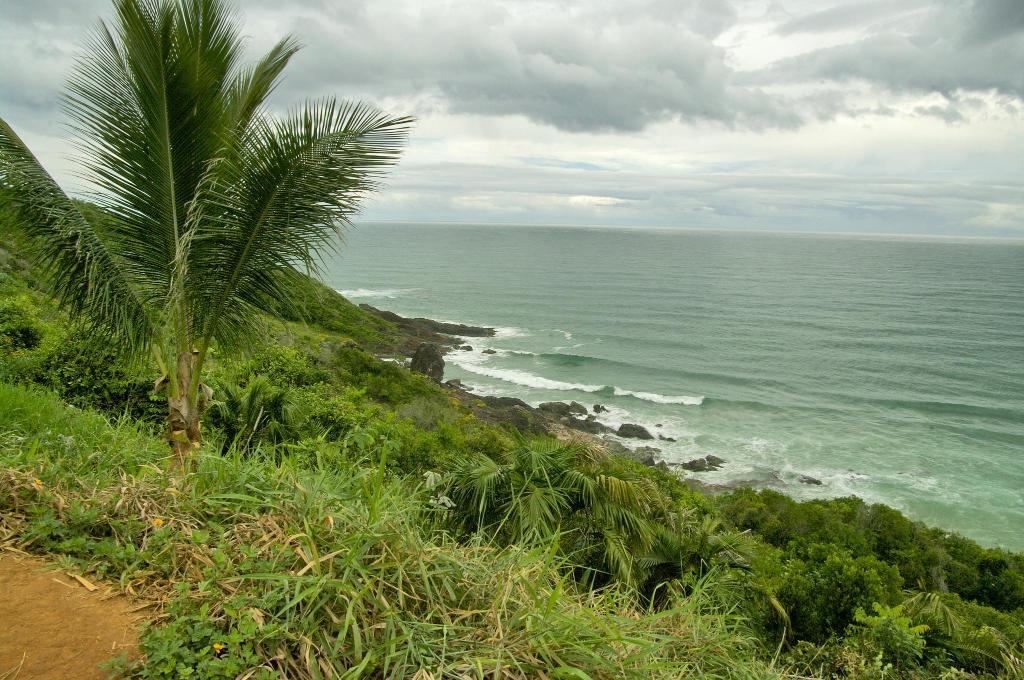What type of terrain is visible in the image? The ground is visible in the image, and there is grass and rocks present. What type of vegetation can be seen in the image? Trees are present in the image. What natural element can be seen in the image? There is water in the image. What is visible in the background of the image? The sky is visible in the background of the image, and clouds are present. What color are the eyes of the person in the image? There is no person present in the image, so there are no eyes to describe. What type of cap is the person wearing in the image? There is no person present in the image, so there is no cap to describe. 